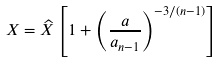<formula> <loc_0><loc_0><loc_500><loc_500>X = \widehat { X } \left [ 1 + \left ( \frac { a } { a _ { n - 1 } } \right ) ^ { - 3 / ( n - 1 ) } \right ]</formula> 